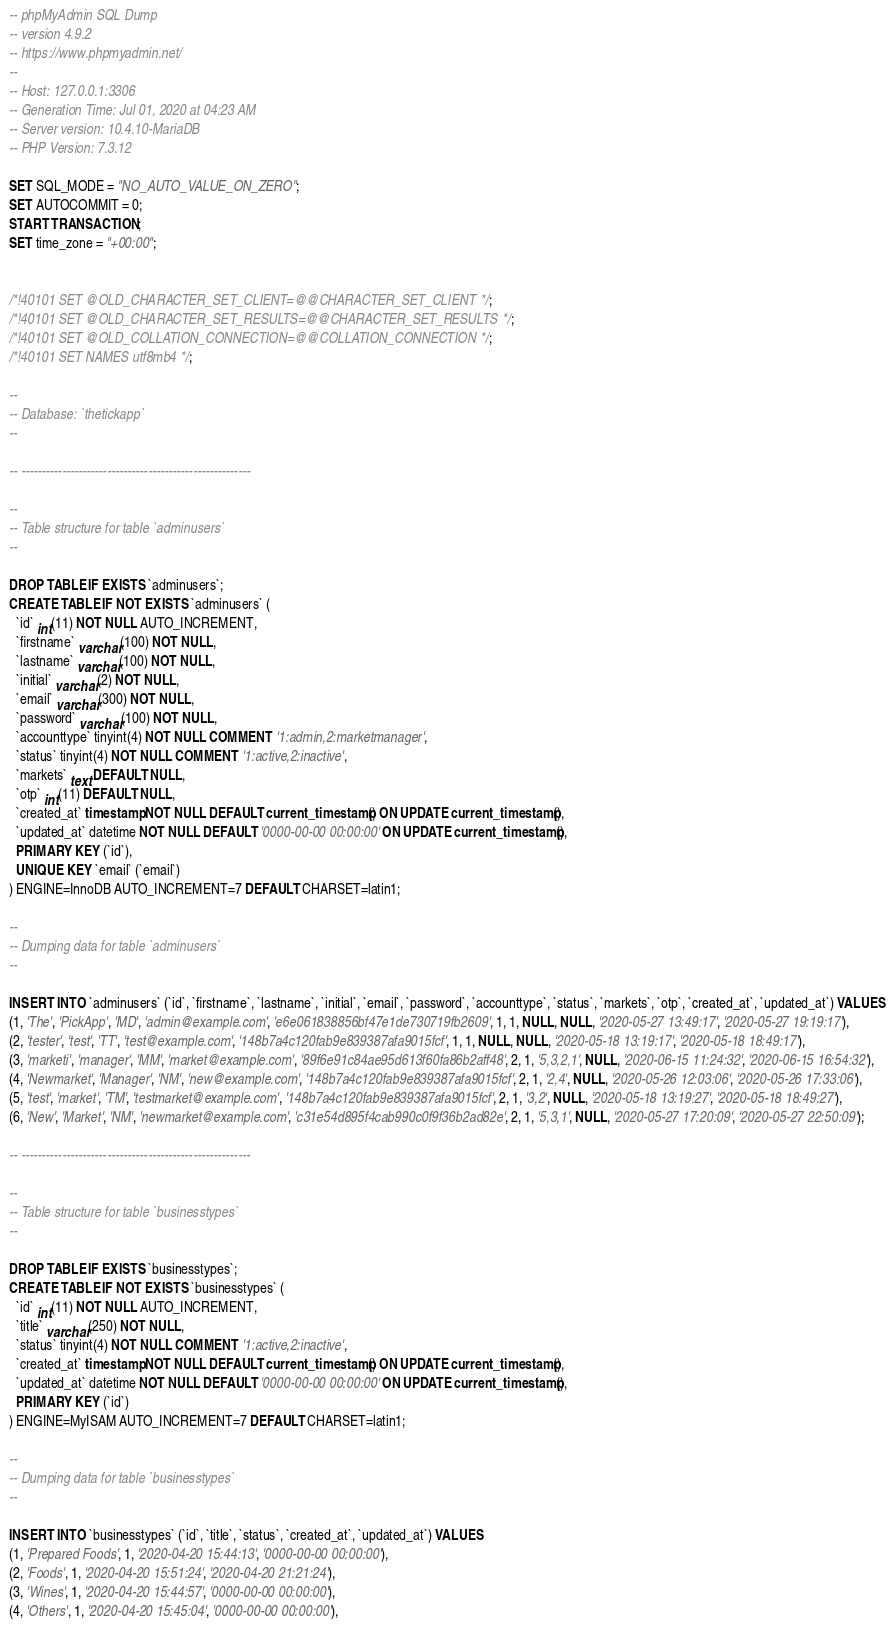Convert code to text. <code><loc_0><loc_0><loc_500><loc_500><_SQL_>-- phpMyAdmin SQL Dump
-- version 4.9.2
-- https://www.phpmyadmin.net/
--
-- Host: 127.0.0.1:3306
-- Generation Time: Jul 01, 2020 at 04:23 AM
-- Server version: 10.4.10-MariaDB
-- PHP Version: 7.3.12

SET SQL_MODE = "NO_AUTO_VALUE_ON_ZERO";
SET AUTOCOMMIT = 0;
START TRANSACTION;
SET time_zone = "+00:00";


/*!40101 SET @OLD_CHARACTER_SET_CLIENT=@@CHARACTER_SET_CLIENT */;
/*!40101 SET @OLD_CHARACTER_SET_RESULTS=@@CHARACTER_SET_RESULTS */;
/*!40101 SET @OLD_COLLATION_CONNECTION=@@COLLATION_CONNECTION */;
/*!40101 SET NAMES utf8mb4 */;

--
-- Database: `thetickapp`
--

-- --------------------------------------------------------

--
-- Table structure for table `adminusers`
--

DROP TABLE IF EXISTS `adminusers`;
CREATE TABLE IF NOT EXISTS `adminusers` (
  `id` int(11) NOT NULL AUTO_INCREMENT,
  `firstname` varchar(100) NOT NULL,
  `lastname` varchar(100) NOT NULL,
  `initial` varchar(2) NOT NULL,
  `email` varchar(300) NOT NULL,
  `password` varchar(100) NOT NULL,
  `accounttype` tinyint(4) NOT NULL COMMENT '1:admin,2:marketmanager',
  `status` tinyint(4) NOT NULL COMMENT '1:active,2:inactive',
  `markets` text DEFAULT NULL,
  `otp` int(11) DEFAULT NULL,
  `created_at` timestamp NOT NULL DEFAULT current_timestamp() ON UPDATE current_timestamp(),
  `updated_at` datetime NOT NULL DEFAULT '0000-00-00 00:00:00' ON UPDATE current_timestamp(),
  PRIMARY KEY (`id`),
  UNIQUE KEY `email` (`email`)
) ENGINE=InnoDB AUTO_INCREMENT=7 DEFAULT CHARSET=latin1;

--
-- Dumping data for table `adminusers`
--

INSERT INTO `adminusers` (`id`, `firstname`, `lastname`, `initial`, `email`, `password`, `accounttype`, `status`, `markets`, `otp`, `created_at`, `updated_at`) VALUES
(1, 'The', 'PickApp', 'MD', 'admin@example.com', 'e6e061838856bf47e1de730719fb2609', 1, 1, NULL, NULL, '2020-05-27 13:49:17', '2020-05-27 19:19:17'),
(2, 'tester', 'test', 'TT', 'test@example.com', '148b7a4c120fab9e839387afa9015fcf', 1, 1, NULL, NULL, '2020-05-18 13:19:17', '2020-05-18 18:49:17'),
(3, 'marketi', 'manager', 'MM', 'market@example.com', '89f6e91c84ae95d613f60fa86b2aff48', 2, 1, '5,3,2,1', NULL, '2020-06-15 11:24:32', '2020-06-15 16:54:32'),
(4, 'Newmarket', 'Manager', 'NM', 'new@example.com', '148b7a4c120fab9e839387afa9015fcf', 2, 1, '2,4', NULL, '2020-05-26 12:03:06', '2020-05-26 17:33:06'),
(5, 'test', 'market', 'TM', 'testmarket@example.com', '148b7a4c120fab9e839387afa9015fcf', 2, 1, '3,2', NULL, '2020-05-18 13:19:27', '2020-05-18 18:49:27'),
(6, 'New', 'Market', 'NM', 'newmarket@example.com', 'c31e54d895f4cab990c0f9f36b2ad82e', 2, 1, '5,3,1', NULL, '2020-05-27 17:20:09', '2020-05-27 22:50:09');

-- --------------------------------------------------------

--
-- Table structure for table `businesstypes`
--

DROP TABLE IF EXISTS `businesstypes`;
CREATE TABLE IF NOT EXISTS `businesstypes` (
  `id` int(11) NOT NULL AUTO_INCREMENT,
  `title` varchar(250) NOT NULL,
  `status` tinyint(4) NOT NULL COMMENT '1:active,2:inactive',
  `created_at` timestamp NOT NULL DEFAULT current_timestamp() ON UPDATE current_timestamp(),
  `updated_at` datetime NOT NULL DEFAULT '0000-00-00 00:00:00' ON UPDATE current_timestamp(),
  PRIMARY KEY (`id`)
) ENGINE=MyISAM AUTO_INCREMENT=7 DEFAULT CHARSET=latin1;

--
-- Dumping data for table `businesstypes`
--

INSERT INTO `businesstypes` (`id`, `title`, `status`, `created_at`, `updated_at`) VALUES
(1, 'Prepared Foods', 1, '2020-04-20 15:44:13', '0000-00-00 00:00:00'),
(2, 'Foods', 1, '2020-04-20 15:51:24', '2020-04-20 21:21:24'),
(3, 'Wines', 1, '2020-04-20 15:44:57', '0000-00-00 00:00:00'),
(4, 'Others', 1, '2020-04-20 15:45:04', '0000-00-00 00:00:00'),</code> 